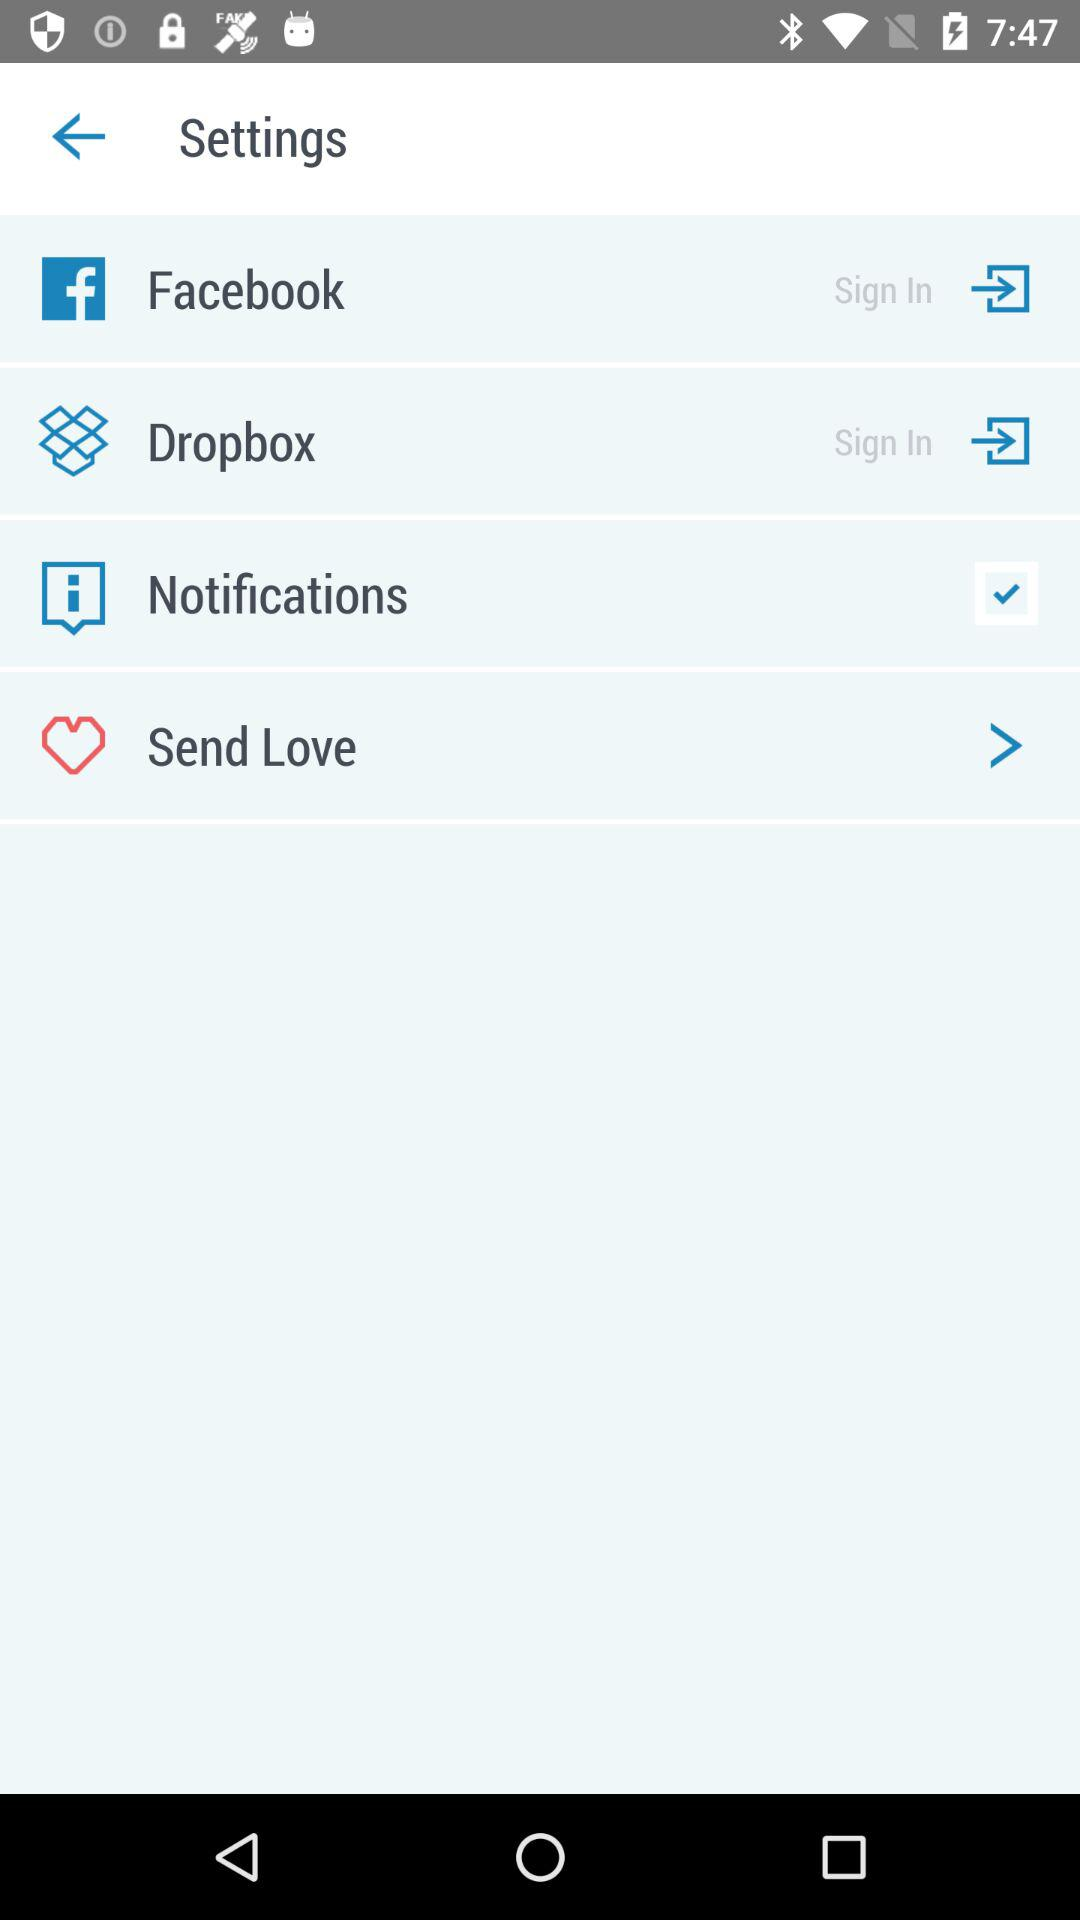Through which applications can we sign up?
When the provided information is insufficient, respond with <no answer>. <no answer> 